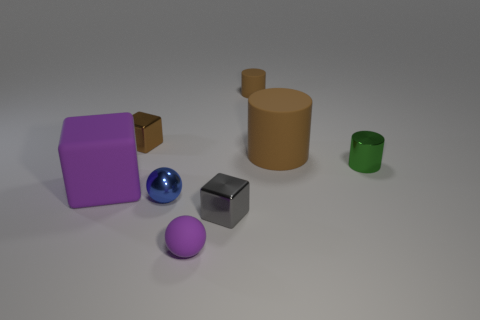There is a matte thing that is left of the small sphere that is right of the small blue shiny object; what number of tiny blue metallic balls are to the right of it?
Offer a very short reply. 1. Do the big matte cylinder and the shiny block to the left of the tiny blue thing have the same color?
Make the answer very short. Yes. What is the size of the blue object that is the same material as the green cylinder?
Keep it short and to the point. Small. Are there more blue objects behind the large purple matte object than big matte balls?
Keep it short and to the point. No. There is a cylinder behind the brown object left of the gray thing that is behind the tiny purple thing; what is its material?
Ensure brevity in your answer.  Rubber. Is the material of the small blue object the same as the cylinder that is behind the small brown cube?
Offer a terse response. No. There is a small green object that is the same shape as the large brown object; what material is it?
Give a very brief answer. Metal. Is there anything else that has the same material as the green object?
Keep it short and to the point. Yes. Are there more small gray cubes behind the large cylinder than small metal objects that are in front of the matte block?
Offer a very short reply. No. There is a small gray object that is made of the same material as the green cylinder; what is its shape?
Offer a very short reply. Cube. 